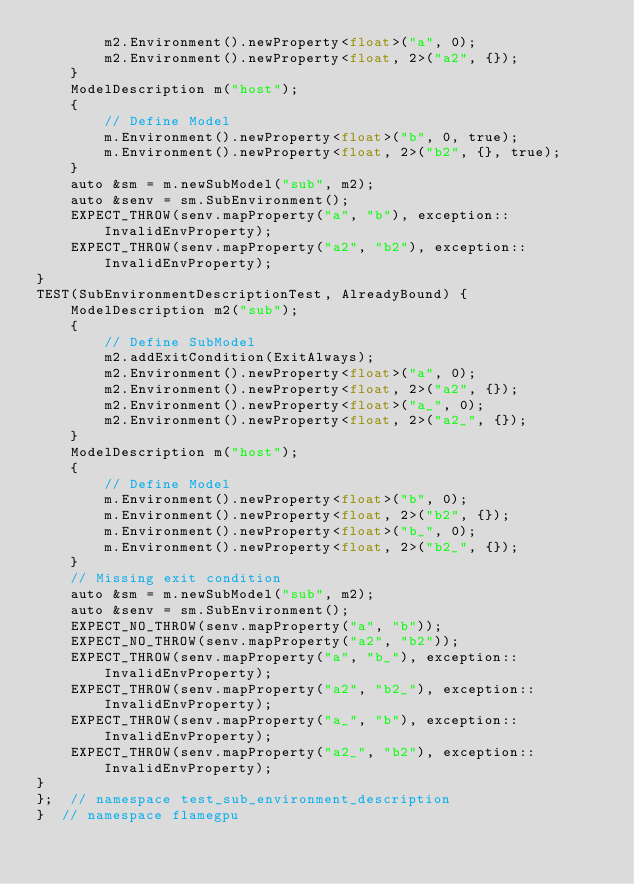Convert code to text. <code><loc_0><loc_0><loc_500><loc_500><_Cuda_>        m2.Environment().newProperty<float>("a", 0);
        m2.Environment().newProperty<float, 2>("a2", {});
    }
    ModelDescription m("host");
    {
        // Define Model
        m.Environment().newProperty<float>("b", 0, true);
        m.Environment().newProperty<float, 2>("b2", {}, true);
    }
    auto &sm = m.newSubModel("sub", m2);
    auto &senv = sm.SubEnvironment();
    EXPECT_THROW(senv.mapProperty("a", "b"), exception::InvalidEnvProperty);
    EXPECT_THROW(senv.mapProperty("a2", "b2"), exception::InvalidEnvProperty);
}
TEST(SubEnvironmentDescriptionTest, AlreadyBound) {
    ModelDescription m2("sub");
    {
        // Define SubModel
        m2.addExitCondition(ExitAlways);
        m2.Environment().newProperty<float>("a", 0);
        m2.Environment().newProperty<float, 2>("a2", {});
        m2.Environment().newProperty<float>("a_", 0);
        m2.Environment().newProperty<float, 2>("a2_", {});
    }
    ModelDescription m("host");
    {
        // Define Model
        m.Environment().newProperty<float>("b", 0);
        m.Environment().newProperty<float, 2>("b2", {});
        m.Environment().newProperty<float>("b_", 0);
        m.Environment().newProperty<float, 2>("b2_", {});
    }
    // Missing exit condition
    auto &sm = m.newSubModel("sub", m2);
    auto &senv = sm.SubEnvironment();
    EXPECT_NO_THROW(senv.mapProperty("a", "b"));
    EXPECT_NO_THROW(senv.mapProperty("a2", "b2"));
    EXPECT_THROW(senv.mapProperty("a", "b_"), exception::InvalidEnvProperty);
    EXPECT_THROW(senv.mapProperty("a2", "b2_"), exception::InvalidEnvProperty);
    EXPECT_THROW(senv.mapProperty("a_", "b"), exception::InvalidEnvProperty);
    EXPECT_THROW(senv.mapProperty("a2_", "b2"), exception::InvalidEnvProperty);
}
};  // namespace test_sub_environment_description
}  // namespace flamegpu
</code> 